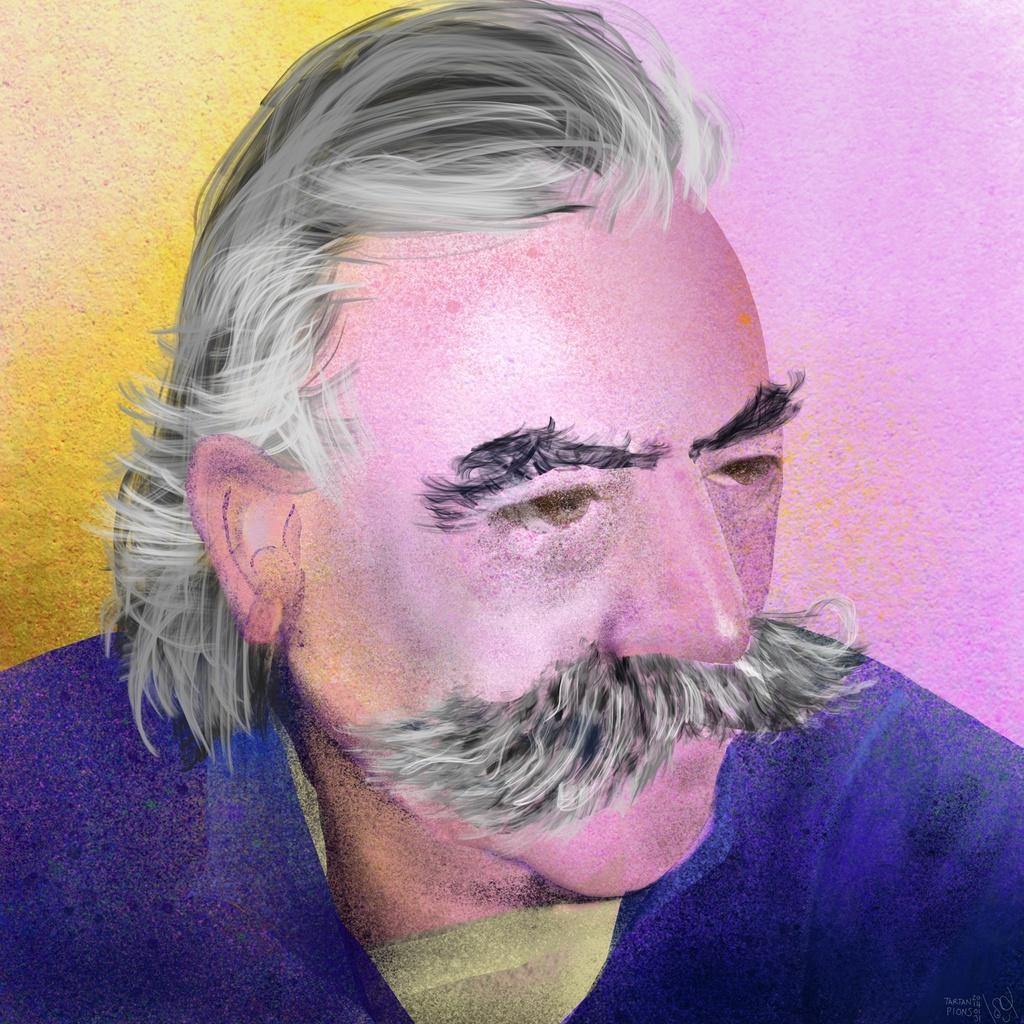How would you summarize this image in a sentence or two? This image consists of a painting. In the middle there is a painting of a man. 